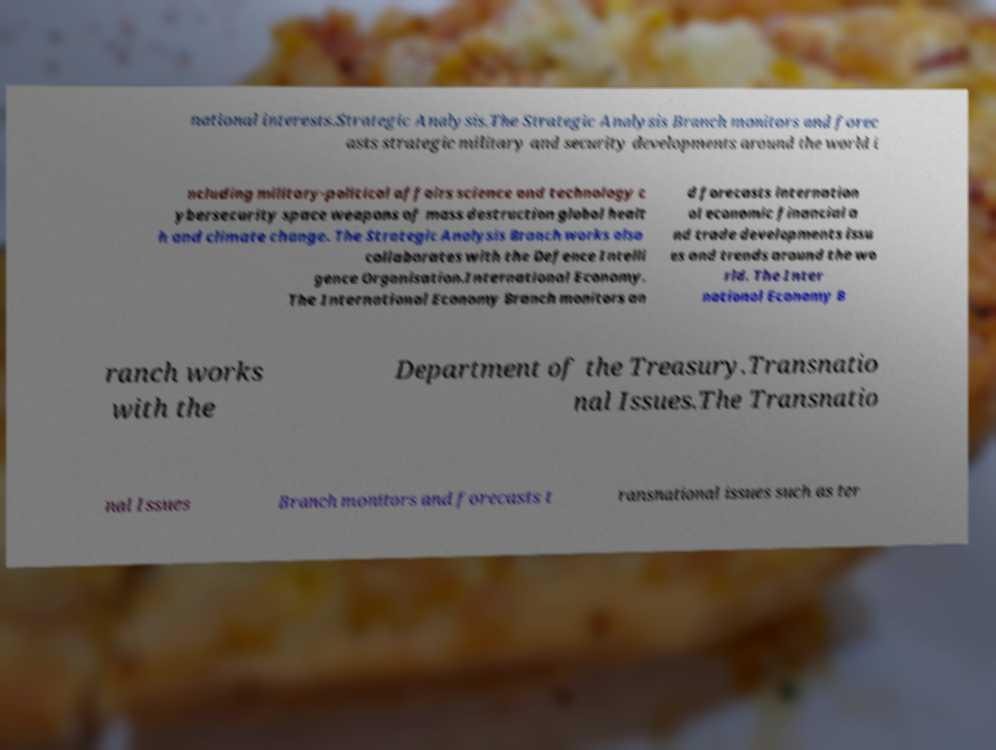Can you read and provide the text displayed in the image?This photo seems to have some interesting text. Can you extract and type it out for me? national interests.Strategic Analysis.The Strategic Analysis Branch monitors and forec asts strategic military and security developments around the world i ncluding military-political affairs science and technology c ybersecurity space weapons of mass destruction global healt h and climate change. The Strategic Analysis Branch works also collaborates with the Defence Intelli gence Organisation.International Economy. The International Economy Branch monitors an d forecasts internation al economic financial a nd trade developments issu es and trends around the wo rld. The Inter national Economy B ranch works with the Department of the Treasury.Transnatio nal Issues.The Transnatio nal Issues Branch monitors and forecasts t ransnational issues such as ter 